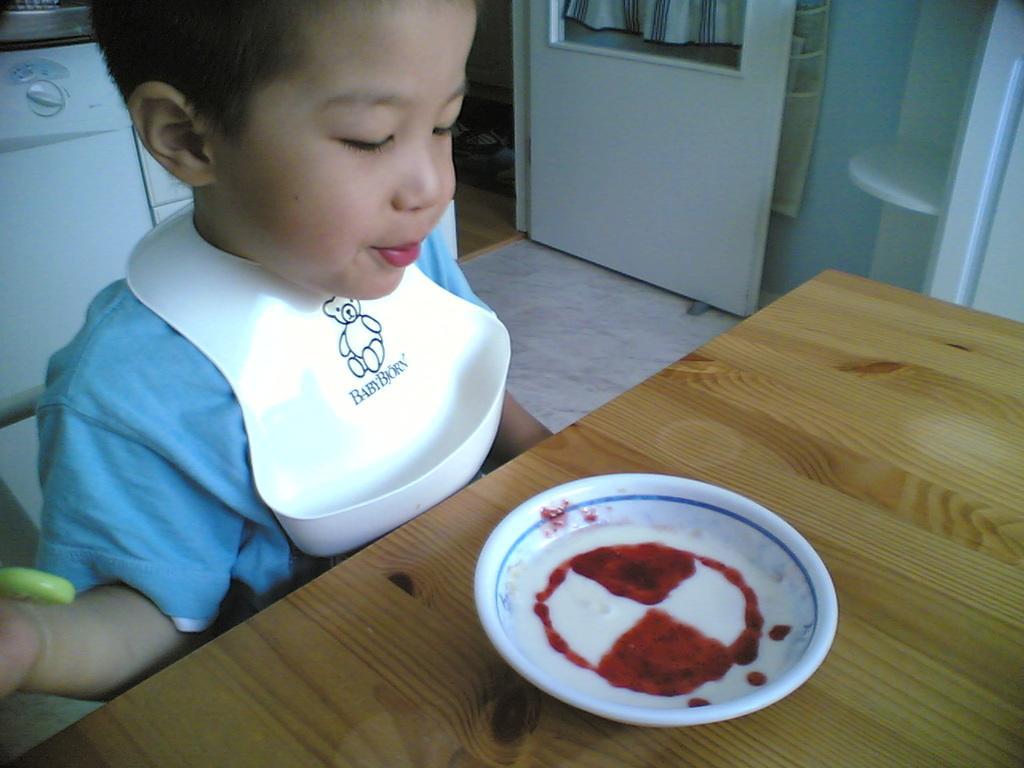How would you summarize this image in a sentence or two? In this image there is a boy sitting in front of table on which we can see there is a plate served with food, behind him there is some machine and door in between the wall. 